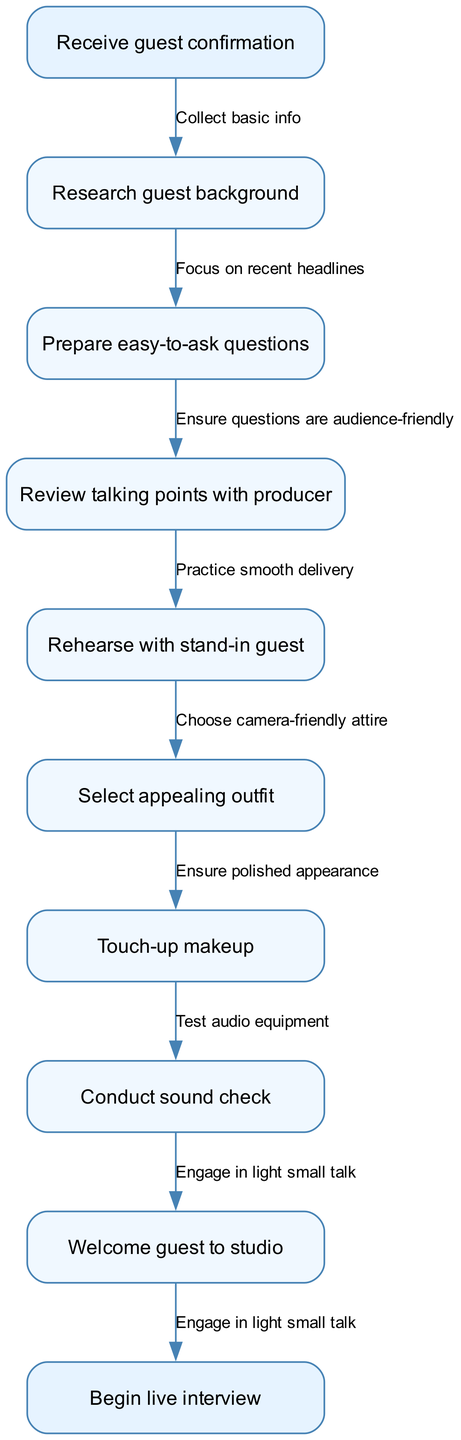What is the starting point of the preparation workflow? The diagram indicates that the workflow begins with the "Receive guest confirmation" node.
Answer: Receive guest confirmation How many nodes are present in this diagram? There are a total of 8 nodes in the diagram, including the start and end nodes.
Answer: 8 What is the final step before the live interview begins? The diagram shows that the last node before starting the live interview is "Welcome guest to studio."
Answer: Welcome guest to studio What is the relationship between "Research guest background" and "Prepare easy-to-ask questions"? The edge connecting these two nodes indicates the flow from "Research guest background" to "Prepare easy-to-ask questions," suggesting that background research is required to formulate questions.
Answer: Focus on recent headlines Which node comes after "Select appealing outfit"? According to the flowchart, the node following "Select appealing outfit" is "Touch-up makeup."
Answer: Touch-up makeup What is the overall objective of this workflow? By reviewing the nodes and flow, the objective of the workflow can be summarized as preparing for a live interview, culminating in the "Begin live interview" step.
Answer: Begin live interview How many edges lead out from the "start" node? The start node has one edge leading to the first intermediate node, which is "Research guest background."
Answer: 1 What action is taken after rehearsing with a stand-in guest? The next step in the workflow after "Rehearse with stand-in guest" is "Select appealing outfit."
Answer: Select appealing outfit 